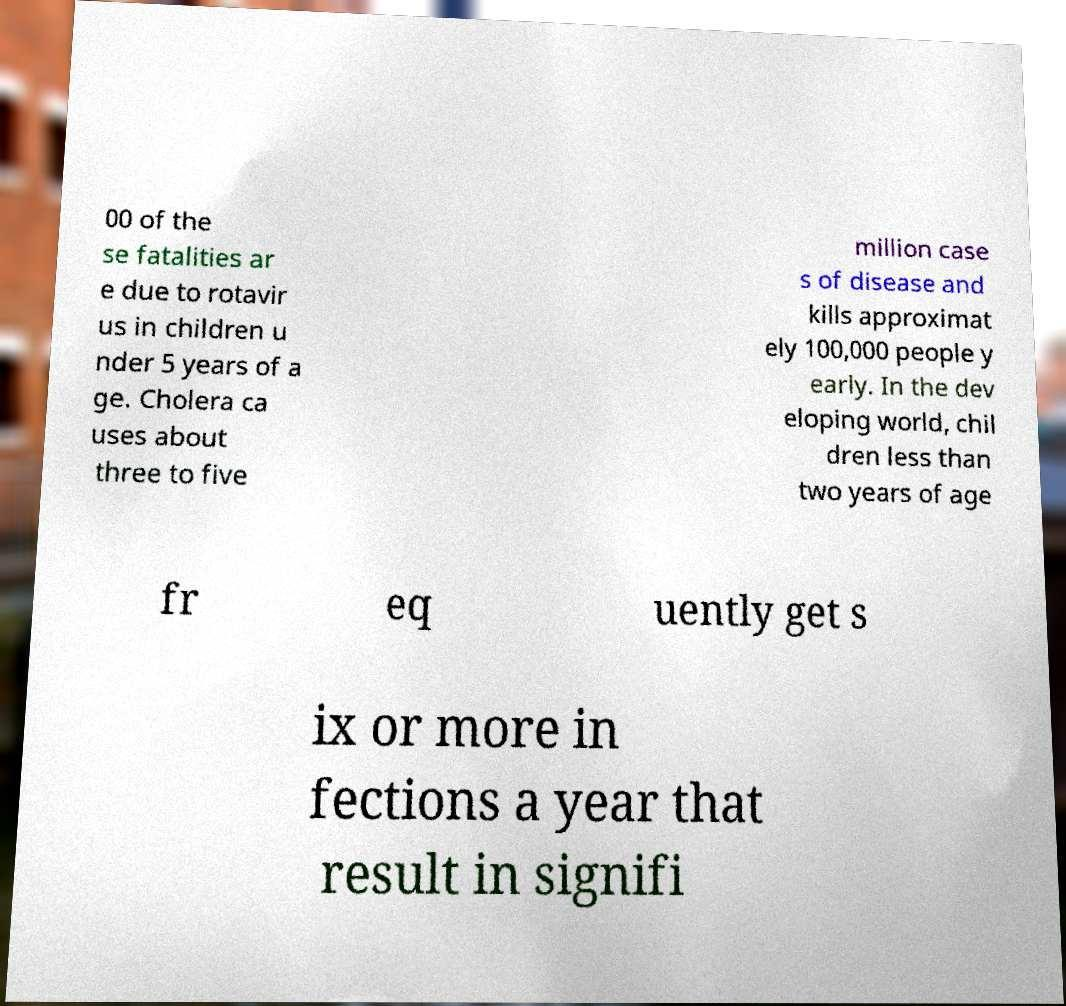For documentation purposes, I need the text within this image transcribed. Could you provide that? 00 of the se fatalities ar e due to rotavir us in children u nder 5 years of a ge. Cholera ca uses about three to five million case s of disease and kills approximat ely 100,000 people y early. In the dev eloping world, chil dren less than two years of age fr eq uently get s ix or more in fections a year that result in signifi 